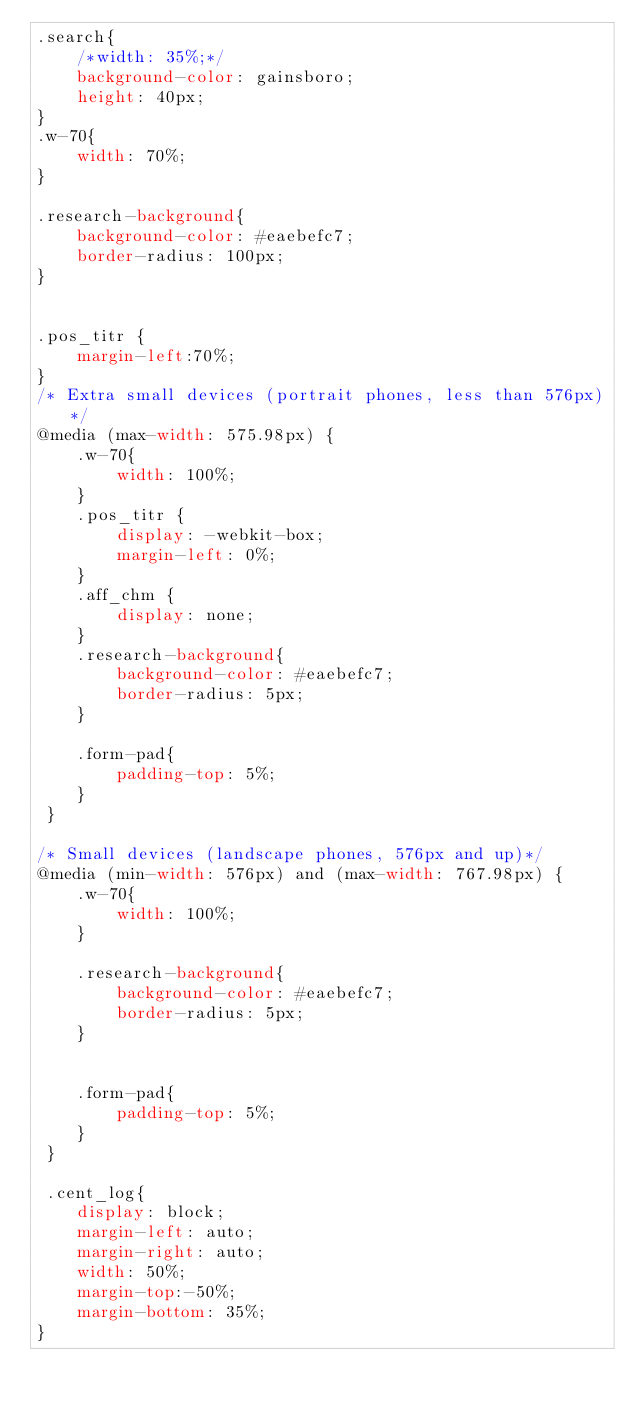Convert code to text. <code><loc_0><loc_0><loc_500><loc_500><_CSS_>.search{
    /*width: 35%;*/
    background-color: gainsboro;
    height: 40px;
}
.w-70{
    width: 70%;
}

.research-background{
    background-color: #eaebefc7;
    border-radius: 100px;
}


.pos_titr {
    margin-left:70%;
}
/* Extra small devices (portrait phones, less than 576px)*/
@media (max-width: 575.98px) {   
    .w-70{
        width: 100%;
    }
    .pos_titr {
        display: -webkit-box;
        margin-left: 0%;
    }
    .aff_chm {
        display: none;
    }
    .research-background{
        background-color: #eaebefc7;
        border-radius: 5px;
    }

    .form-pad{
        padding-top: 5%;
    }
 }

/* Small devices (landscape phones, 576px and up)*/
@media (min-width: 576px) and (max-width: 767.98px) {    
    .w-70{
        width: 100%;
    }

    .research-background{
        background-color: #eaebefc7;
        border-radius: 5px;
    }

        
    .form-pad{
        padding-top: 5%;
    }
 }

 .cent_log{
    display: block;
    margin-left: auto;
    margin-right: auto;
    width: 50%;
    margin-top:-50%;
    margin-bottom: 35%;
}</code> 